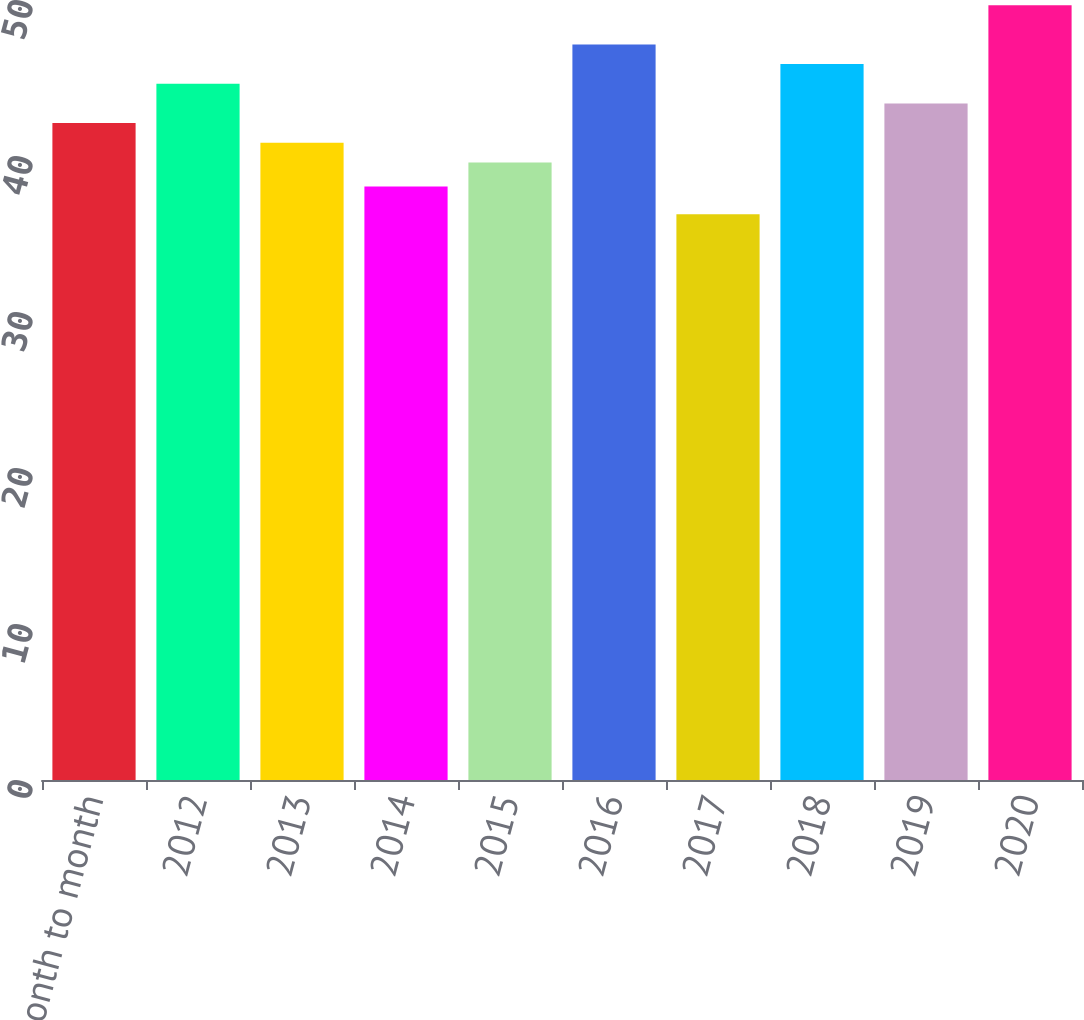<chart> <loc_0><loc_0><loc_500><loc_500><bar_chart><fcel>Month to month<fcel>2012<fcel>2013<fcel>2014<fcel>2015<fcel>2016<fcel>2017<fcel>2018<fcel>2019<fcel>2020<nl><fcel>42.11<fcel>44.63<fcel>40.85<fcel>38.04<fcel>39.59<fcel>47.15<fcel>36.26<fcel>45.89<fcel>43.37<fcel>49.67<nl></chart> 